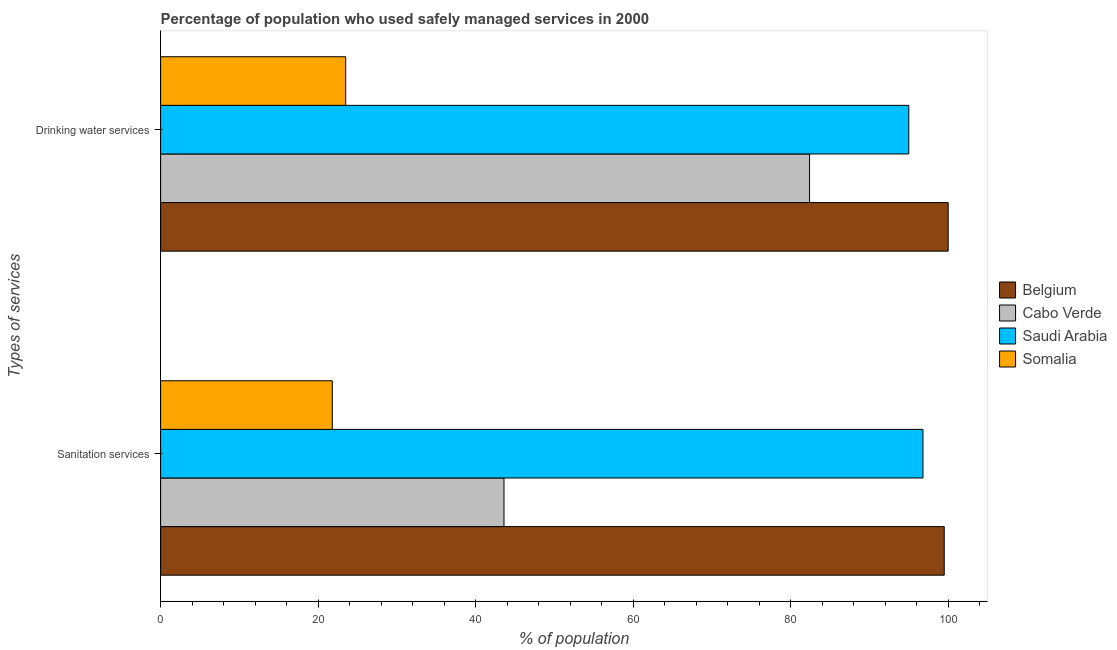What is the label of the 2nd group of bars from the top?
Your answer should be compact. Sanitation services. What is the percentage of population who used drinking water services in Cabo Verde?
Give a very brief answer. 82.4. Across all countries, what is the maximum percentage of population who used drinking water services?
Your answer should be very brief. 100. Across all countries, what is the minimum percentage of population who used drinking water services?
Keep it short and to the point. 23.5. In which country was the percentage of population who used drinking water services maximum?
Your answer should be very brief. Belgium. In which country was the percentage of population who used sanitation services minimum?
Offer a terse response. Somalia. What is the total percentage of population who used sanitation services in the graph?
Provide a succinct answer. 261.7. What is the difference between the percentage of population who used sanitation services in Cabo Verde and that in Saudi Arabia?
Ensure brevity in your answer.  -53.2. What is the difference between the percentage of population who used drinking water services in Saudi Arabia and the percentage of population who used sanitation services in Somalia?
Provide a short and direct response. 73.2. What is the average percentage of population who used drinking water services per country?
Your answer should be very brief. 75.22. What is the difference between the percentage of population who used drinking water services and percentage of population who used sanitation services in Belgium?
Make the answer very short. 0.5. In how many countries, is the percentage of population who used drinking water services greater than 36 %?
Offer a very short reply. 3. What is the ratio of the percentage of population who used drinking water services in Cabo Verde to that in Belgium?
Your answer should be very brief. 0.82. What does the 3rd bar from the top in Sanitation services represents?
Provide a short and direct response. Cabo Verde. How many bars are there?
Your response must be concise. 8. Are all the bars in the graph horizontal?
Your answer should be compact. Yes. Are the values on the major ticks of X-axis written in scientific E-notation?
Your response must be concise. No. Does the graph contain any zero values?
Offer a terse response. No. Does the graph contain grids?
Your answer should be compact. No. Where does the legend appear in the graph?
Offer a terse response. Center right. How many legend labels are there?
Ensure brevity in your answer.  4. What is the title of the graph?
Keep it short and to the point. Percentage of population who used safely managed services in 2000. Does "Azerbaijan" appear as one of the legend labels in the graph?
Your answer should be very brief. No. What is the label or title of the X-axis?
Ensure brevity in your answer.  % of population. What is the label or title of the Y-axis?
Provide a succinct answer. Types of services. What is the % of population in Belgium in Sanitation services?
Offer a very short reply. 99.5. What is the % of population of Cabo Verde in Sanitation services?
Offer a very short reply. 43.6. What is the % of population in Saudi Arabia in Sanitation services?
Provide a short and direct response. 96.8. What is the % of population of Somalia in Sanitation services?
Your answer should be compact. 21.8. What is the % of population of Belgium in Drinking water services?
Ensure brevity in your answer.  100. What is the % of population of Cabo Verde in Drinking water services?
Give a very brief answer. 82.4. What is the % of population of Somalia in Drinking water services?
Give a very brief answer. 23.5. Across all Types of services, what is the maximum % of population in Belgium?
Your answer should be very brief. 100. Across all Types of services, what is the maximum % of population in Cabo Verde?
Offer a very short reply. 82.4. Across all Types of services, what is the maximum % of population in Saudi Arabia?
Offer a very short reply. 96.8. Across all Types of services, what is the maximum % of population of Somalia?
Your answer should be very brief. 23.5. Across all Types of services, what is the minimum % of population of Belgium?
Your response must be concise. 99.5. Across all Types of services, what is the minimum % of population in Cabo Verde?
Make the answer very short. 43.6. Across all Types of services, what is the minimum % of population of Somalia?
Your response must be concise. 21.8. What is the total % of population of Belgium in the graph?
Make the answer very short. 199.5. What is the total % of population of Cabo Verde in the graph?
Give a very brief answer. 126. What is the total % of population in Saudi Arabia in the graph?
Offer a terse response. 191.8. What is the total % of population in Somalia in the graph?
Provide a short and direct response. 45.3. What is the difference between the % of population in Belgium in Sanitation services and that in Drinking water services?
Make the answer very short. -0.5. What is the difference between the % of population of Cabo Verde in Sanitation services and that in Drinking water services?
Your response must be concise. -38.8. What is the difference between the % of population in Belgium in Sanitation services and the % of population in Saudi Arabia in Drinking water services?
Offer a terse response. 4.5. What is the difference between the % of population of Belgium in Sanitation services and the % of population of Somalia in Drinking water services?
Ensure brevity in your answer.  76. What is the difference between the % of population of Cabo Verde in Sanitation services and the % of population of Saudi Arabia in Drinking water services?
Keep it short and to the point. -51.4. What is the difference between the % of population of Cabo Verde in Sanitation services and the % of population of Somalia in Drinking water services?
Your response must be concise. 20.1. What is the difference between the % of population of Saudi Arabia in Sanitation services and the % of population of Somalia in Drinking water services?
Provide a short and direct response. 73.3. What is the average % of population of Belgium per Types of services?
Offer a terse response. 99.75. What is the average % of population of Saudi Arabia per Types of services?
Provide a succinct answer. 95.9. What is the average % of population in Somalia per Types of services?
Offer a very short reply. 22.65. What is the difference between the % of population of Belgium and % of population of Cabo Verde in Sanitation services?
Offer a very short reply. 55.9. What is the difference between the % of population in Belgium and % of population in Somalia in Sanitation services?
Your response must be concise. 77.7. What is the difference between the % of population in Cabo Verde and % of population in Saudi Arabia in Sanitation services?
Your answer should be very brief. -53.2. What is the difference between the % of population of Cabo Verde and % of population of Somalia in Sanitation services?
Your response must be concise. 21.8. What is the difference between the % of population of Saudi Arabia and % of population of Somalia in Sanitation services?
Your answer should be very brief. 75. What is the difference between the % of population in Belgium and % of population in Cabo Verde in Drinking water services?
Your response must be concise. 17.6. What is the difference between the % of population in Belgium and % of population in Somalia in Drinking water services?
Your answer should be compact. 76.5. What is the difference between the % of population in Cabo Verde and % of population in Somalia in Drinking water services?
Your response must be concise. 58.9. What is the difference between the % of population in Saudi Arabia and % of population in Somalia in Drinking water services?
Your response must be concise. 71.5. What is the ratio of the % of population in Cabo Verde in Sanitation services to that in Drinking water services?
Offer a very short reply. 0.53. What is the ratio of the % of population in Saudi Arabia in Sanitation services to that in Drinking water services?
Your answer should be compact. 1.02. What is the ratio of the % of population in Somalia in Sanitation services to that in Drinking water services?
Make the answer very short. 0.93. What is the difference between the highest and the second highest % of population of Cabo Verde?
Your answer should be compact. 38.8. What is the difference between the highest and the lowest % of population in Belgium?
Provide a succinct answer. 0.5. What is the difference between the highest and the lowest % of population in Cabo Verde?
Give a very brief answer. 38.8. What is the difference between the highest and the lowest % of population of Saudi Arabia?
Provide a short and direct response. 1.8. 